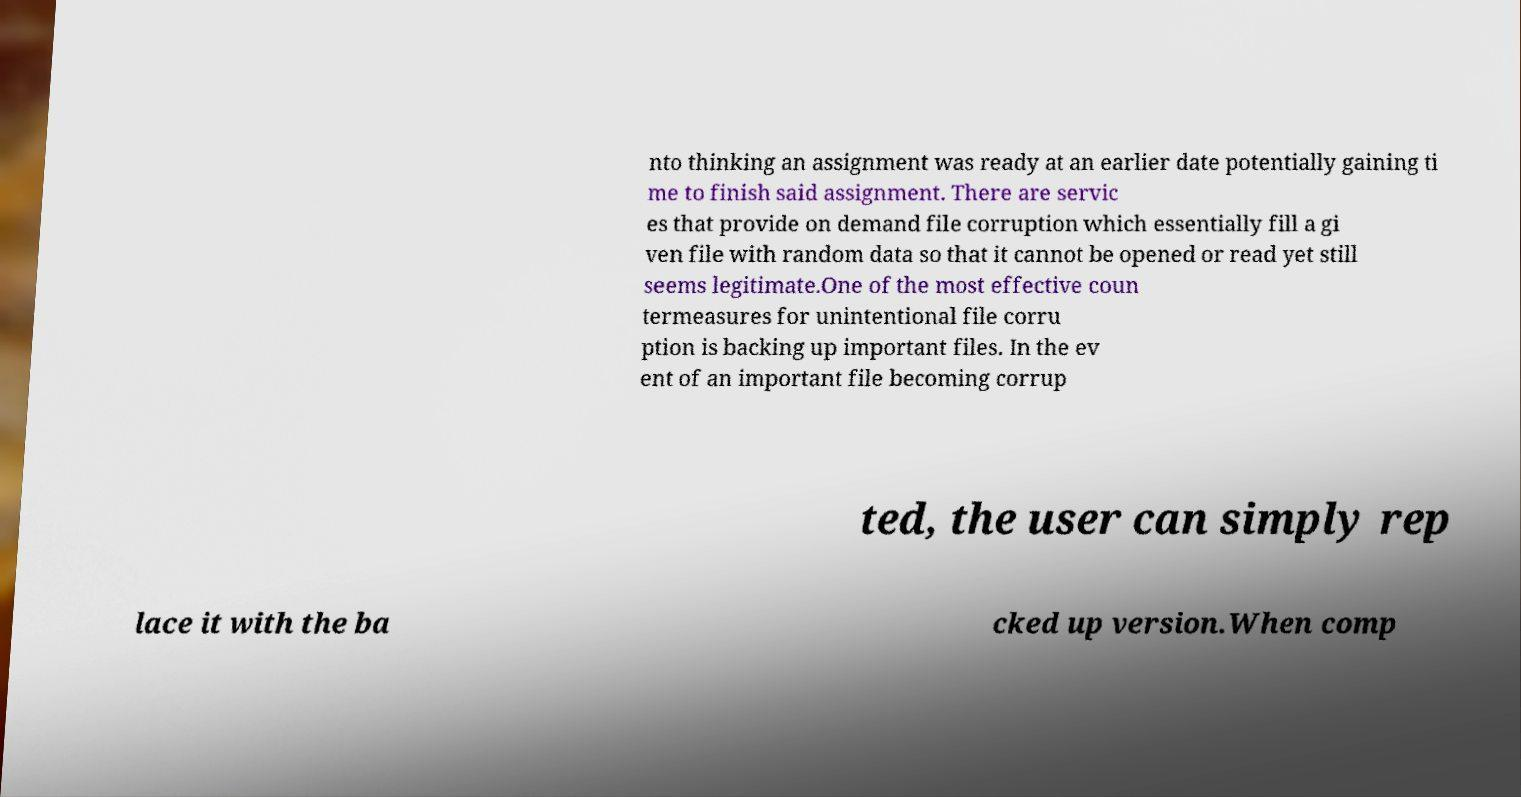Can you read and provide the text displayed in the image?This photo seems to have some interesting text. Can you extract and type it out for me? nto thinking an assignment was ready at an earlier date potentially gaining ti me to finish said assignment. There are servic es that provide on demand file corruption which essentially fill a gi ven file with random data so that it cannot be opened or read yet still seems legitimate.One of the most effective coun termeasures for unintentional file corru ption is backing up important files. In the ev ent of an important file becoming corrup ted, the user can simply rep lace it with the ba cked up version.When comp 